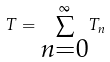Convert formula to latex. <formula><loc_0><loc_0><loc_500><loc_500>T = \overset { \infty } { \sum _ { \substack { n = 0 } } } T _ { n }</formula> 